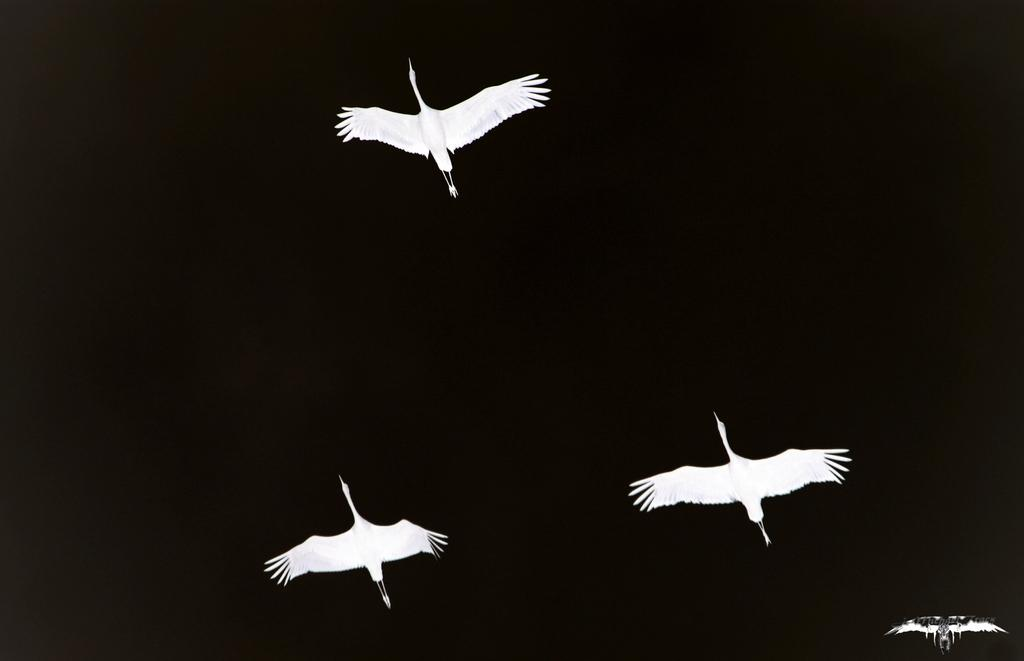What type of animals can be seen in the image? There are birds in the image. What are the birds doing in the image? The birds are flying in the air. What is the color of the background in the image? The background of the image is dark. What type of milk can be seen being poured into a glass in the image? There is no milk or glass present in the image; it features birds flying in the air with a dark background. What type of game is being played by the birds in the image? There is no game being played by the birds in the image; they are simply flying in the air. 